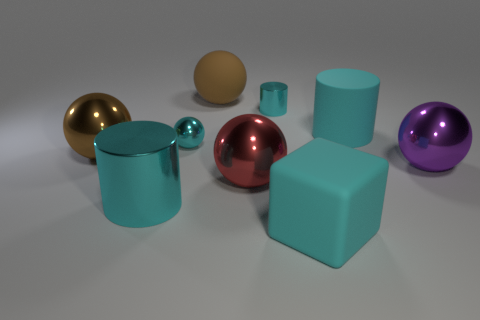What number of tiny yellow metallic things are there?
Make the answer very short. 0. Does the big brown sphere that is behind the rubber cylinder have the same material as the red sphere?
Give a very brief answer. No. The large ball that is both behind the big purple thing and on the right side of the brown metallic thing is made of what material?
Make the answer very short. Rubber. There is a metal sphere that is the same color as the tiny cylinder; what size is it?
Make the answer very short. Small. There is a brown sphere left of the large object behind the cyan matte cylinder; what is it made of?
Your response must be concise. Metal. There is a brown thing behind the small cyan metallic thing that is on the right side of the large metallic sphere that is in front of the purple sphere; how big is it?
Offer a terse response. Large. What number of big cyan cylinders are the same material as the tiny sphere?
Your answer should be compact. 1. What color is the large metal ball that is to the right of the metal cylinder behind the brown metallic sphere?
Provide a short and direct response. Purple. What number of things are red metallic spheres or things in front of the brown metal ball?
Ensure brevity in your answer.  4. Is there a big shiny thing that has the same color as the large block?
Keep it short and to the point. Yes. 